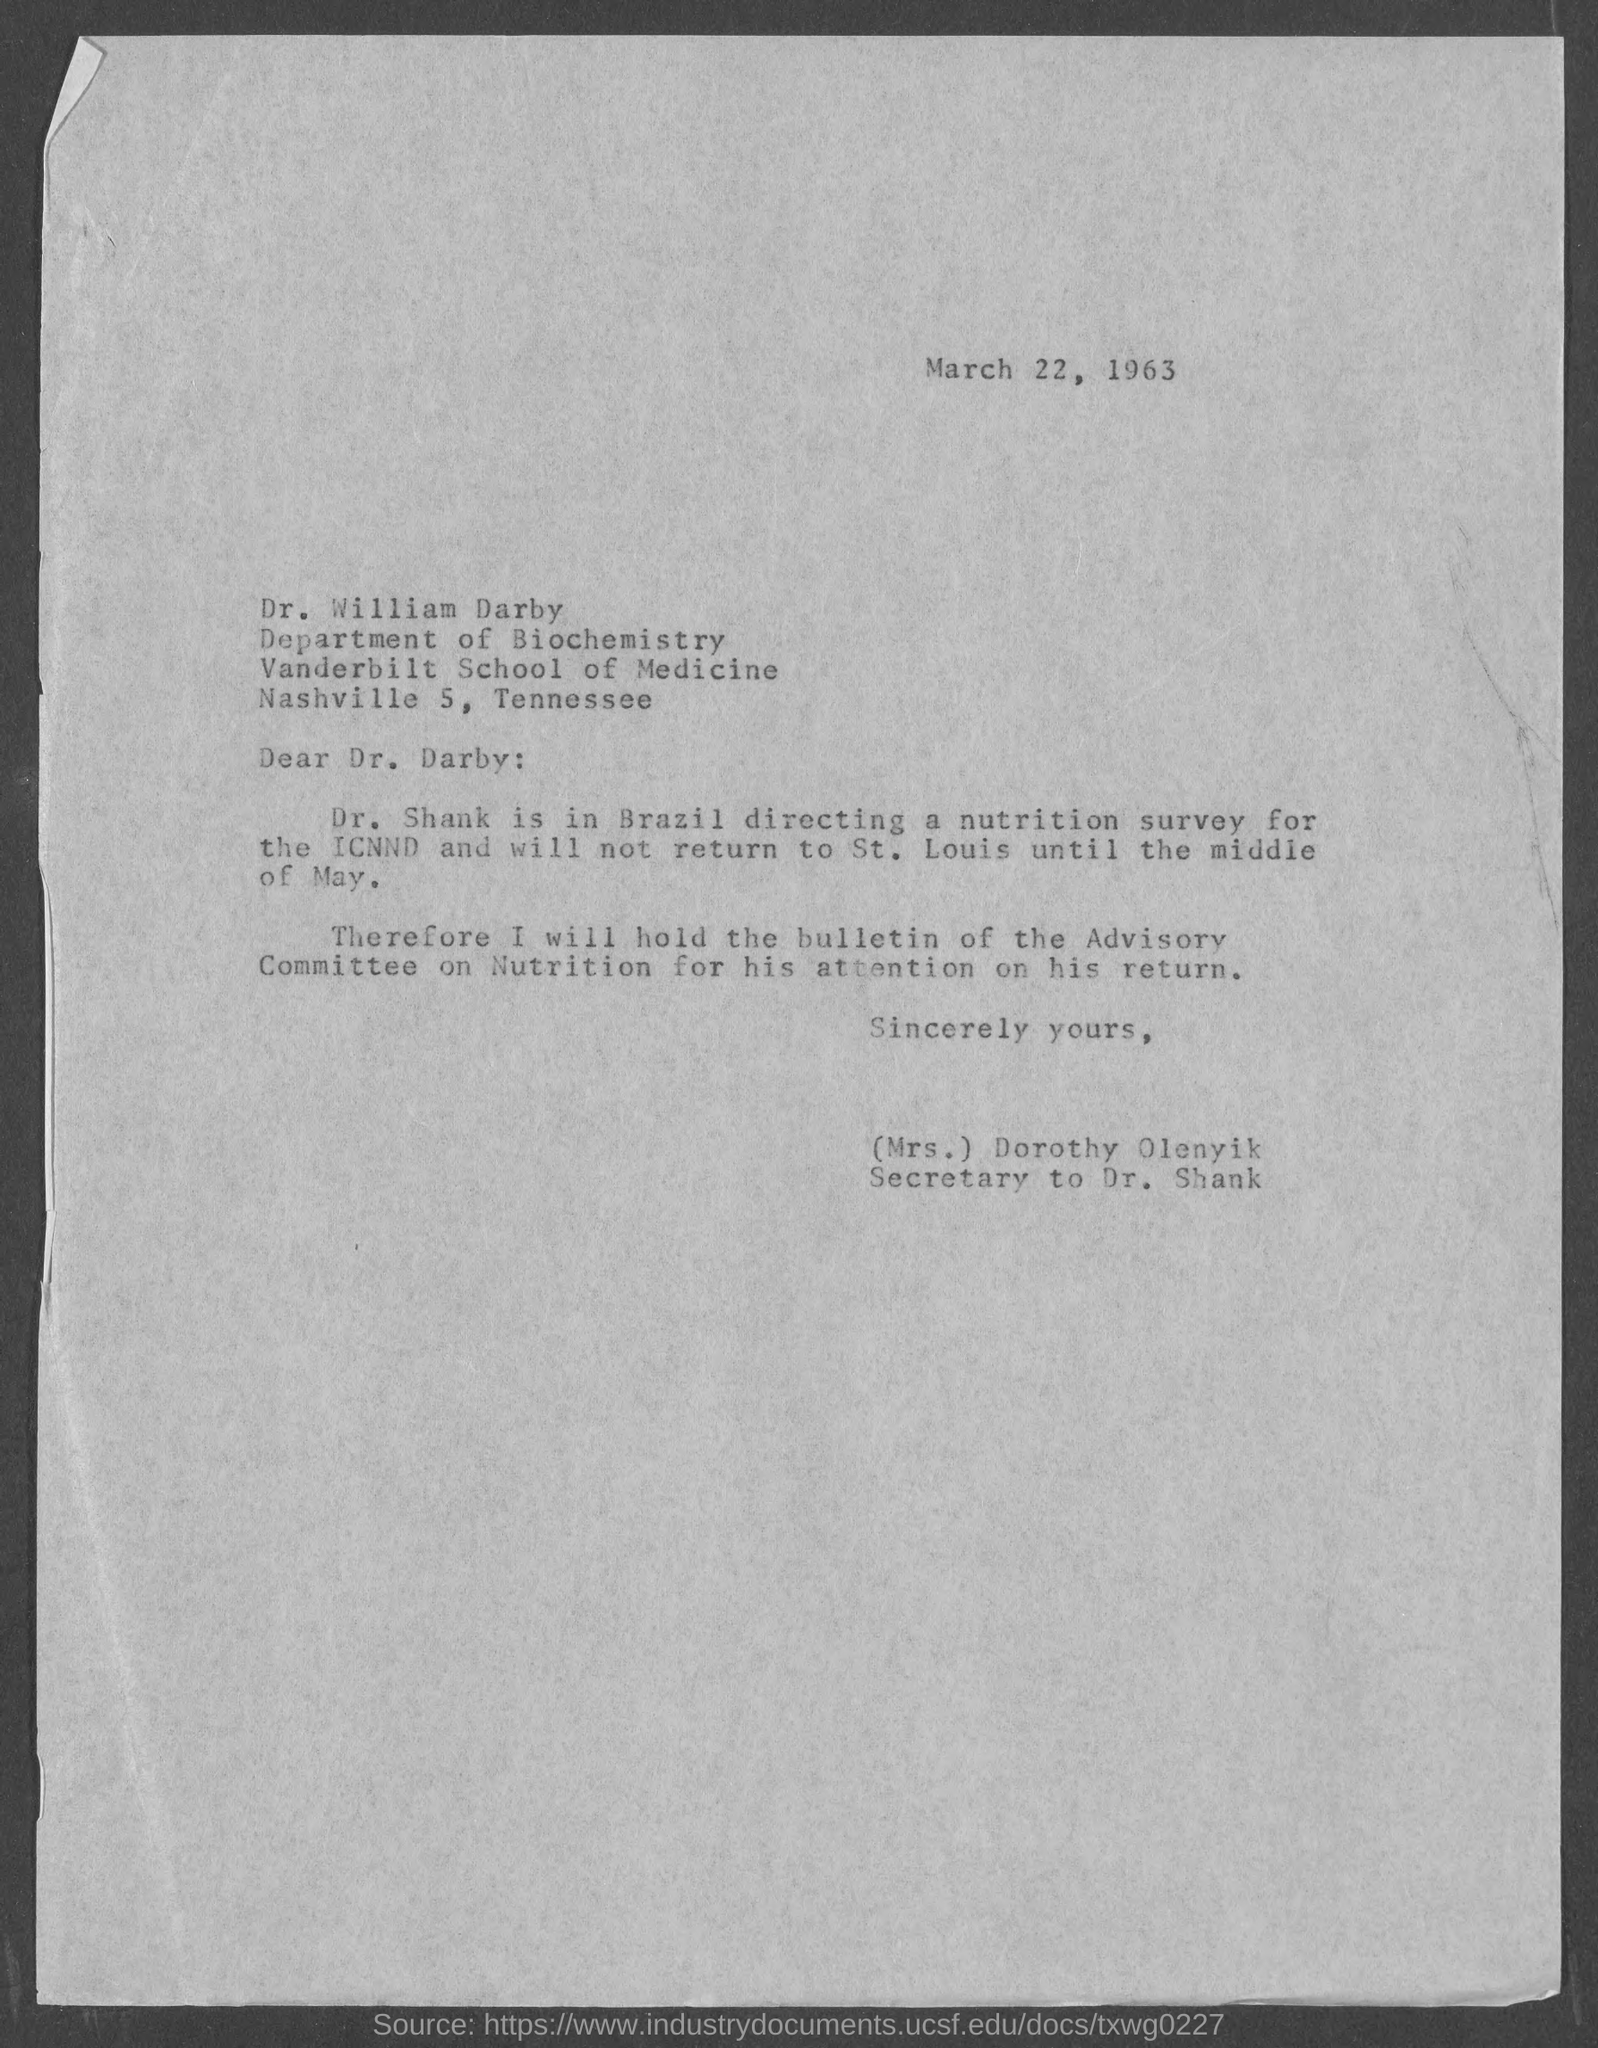List a handful of essential elements in this visual. The date on the letter is March 22, 1963. The letter is from Mrs. Dorothy Olenyik. Dr. Shank is located in Brazil. The letter is addressed to Dr. William Darby. 